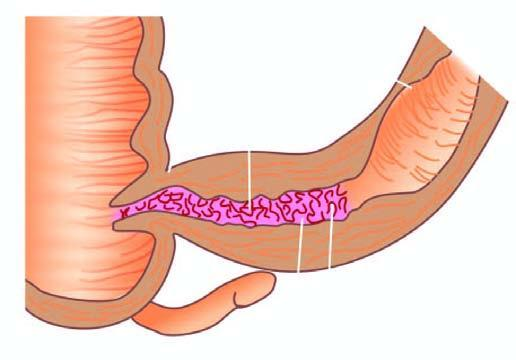what does luminal surface of longitudinal cut section show?
Answer the question using a single word or phrase. Segment of thickened wall with narrow lumen 